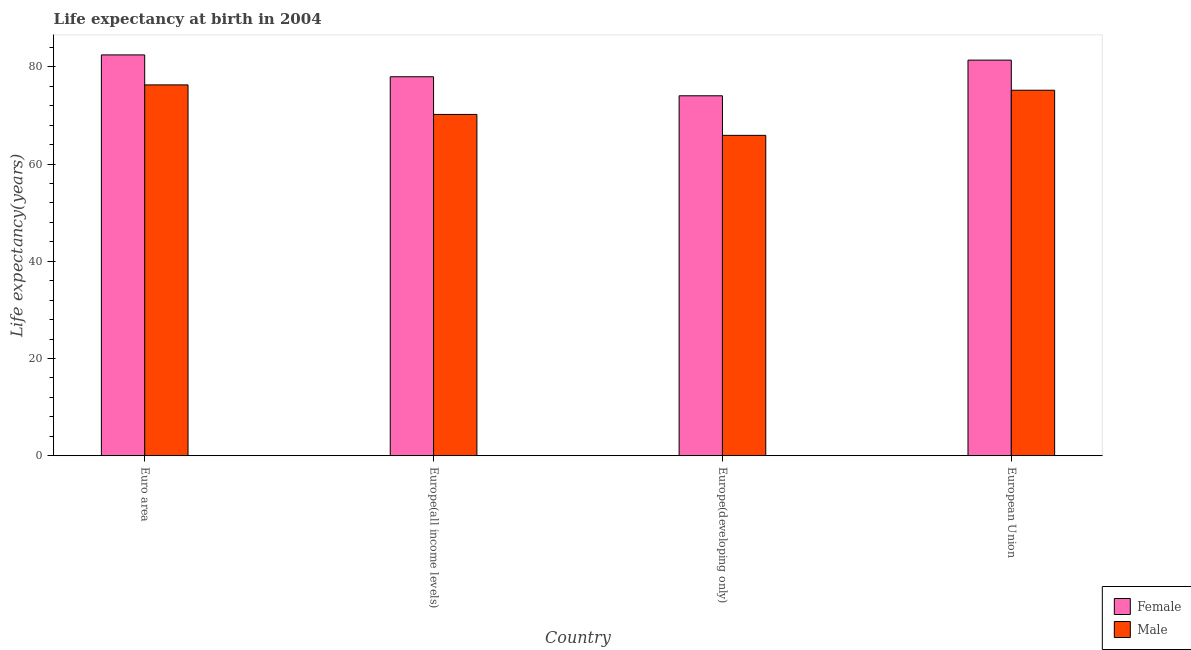How many different coloured bars are there?
Make the answer very short. 2. How many groups of bars are there?
Ensure brevity in your answer.  4. Are the number of bars per tick equal to the number of legend labels?
Offer a very short reply. Yes. What is the label of the 2nd group of bars from the left?
Your answer should be compact. Europe(all income levels). What is the life expectancy(male) in Europe(all income levels)?
Provide a short and direct response. 70.2. Across all countries, what is the maximum life expectancy(female)?
Your answer should be very brief. 82.44. Across all countries, what is the minimum life expectancy(male)?
Keep it short and to the point. 65.9. In which country was the life expectancy(female) minimum?
Make the answer very short. Europe(developing only). What is the total life expectancy(female) in the graph?
Keep it short and to the point. 315.79. What is the difference between the life expectancy(female) in Europe(developing only) and that in European Union?
Offer a terse response. -7.33. What is the difference between the life expectancy(female) in Euro area and the life expectancy(male) in Europe(developing only)?
Offer a very short reply. 16.54. What is the average life expectancy(female) per country?
Keep it short and to the point. 78.95. What is the difference between the life expectancy(female) and life expectancy(male) in European Union?
Your answer should be very brief. 6.19. In how many countries, is the life expectancy(male) greater than 32 years?
Give a very brief answer. 4. What is the ratio of the life expectancy(male) in Europe(developing only) to that in European Union?
Keep it short and to the point. 0.88. What is the difference between the highest and the second highest life expectancy(male)?
Provide a short and direct response. 1.1. What is the difference between the highest and the lowest life expectancy(female)?
Your answer should be compact. 8.41. Is the sum of the life expectancy(male) in Euro area and Europe(all income levels) greater than the maximum life expectancy(female) across all countries?
Give a very brief answer. Yes. What does the 2nd bar from the left in European Union represents?
Ensure brevity in your answer.  Male. What does the 2nd bar from the right in Euro area represents?
Make the answer very short. Female. How many bars are there?
Provide a succinct answer. 8. Are the values on the major ticks of Y-axis written in scientific E-notation?
Make the answer very short. No. Where does the legend appear in the graph?
Your response must be concise. Bottom right. What is the title of the graph?
Your response must be concise. Life expectancy at birth in 2004. Does "National Tourists" appear as one of the legend labels in the graph?
Your response must be concise. No. What is the label or title of the Y-axis?
Offer a very short reply. Life expectancy(years). What is the Life expectancy(years) of Female in Euro area?
Provide a succinct answer. 82.44. What is the Life expectancy(years) of Male in Euro area?
Your answer should be very brief. 76.27. What is the Life expectancy(years) of Female in Europe(all income levels)?
Your answer should be compact. 77.95. What is the Life expectancy(years) in Male in Europe(all income levels)?
Offer a terse response. 70.2. What is the Life expectancy(years) in Female in Europe(developing only)?
Offer a terse response. 74.03. What is the Life expectancy(years) in Male in Europe(developing only)?
Keep it short and to the point. 65.9. What is the Life expectancy(years) in Female in European Union?
Your response must be concise. 81.37. What is the Life expectancy(years) in Male in European Union?
Provide a short and direct response. 75.18. Across all countries, what is the maximum Life expectancy(years) of Female?
Ensure brevity in your answer.  82.44. Across all countries, what is the maximum Life expectancy(years) in Male?
Your answer should be very brief. 76.27. Across all countries, what is the minimum Life expectancy(years) in Female?
Your response must be concise. 74.03. Across all countries, what is the minimum Life expectancy(years) in Male?
Provide a short and direct response. 65.9. What is the total Life expectancy(years) in Female in the graph?
Your answer should be compact. 315.79. What is the total Life expectancy(years) in Male in the graph?
Give a very brief answer. 287.55. What is the difference between the Life expectancy(years) in Female in Euro area and that in Europe(all income levels)?
Your response must be concise. 4.49. What is the difference between the Life expectancy(years) in Male in Euro area and that in Europe(all income levels)?
Give a very brief answer. 6.07. What is the difference between the Life expectancy(years) in Female in Euro area and that in Europe(developing only)?
Your answer should be very brief. 8.41. What is the difference between the Life expectancy(years) of Male in Euro area and that in Europe(developing only)?
Offer a very short reply. 10.38. What is the difference between the Life expectancy(years) in Female in Euro area and that in European Union?
Ensure brevity in your answer.  1.07. What is the difference between the Life expectancy(years) of Male in Euro area and that in European Union?
Provide a succinct answer. 1.1. What is the difference between the Life expectancy(years) of Female in Europe(all income levels) and that in Europe(developing only)?
Ensure brevity in your answer.  3.91. What is the difference between the Life expectancy(years) of Male in Europe(all income levels) and that in Europe(developing only)?
Offer a terse response. 4.3. What is the difference between the Life expectancy(years) in Female in Europe(all income levels) and that in European Union?
Your response must be concise. -3.42. What is the difference between the Life expectancy(years) in Male in Europe(all income levels) and that in European Union?
Provide a short and direct response. -4.98. What is the difference between the Life expectancy(years) of Female in Europe(developing only) and that in European Union?
Provide a short and direct response. -7.33. What is the difference between the Life expectancy(years) of Male in Europe(developing only) and that in European Union?
Your response must be concise. -9.28. What is the difference between the Life expectancy(years) of Female in Euro area and the Life expectancy(years) of Male in Europe(all income levels)?
Make the answer very short. 12.24. What is the difference between the Life expectancy(years) in Female in Euro area and the Life expectancy(years) in Male in Europe(developing only)?
Your answer should be very brief. 16.54. What is the difference between the Life expectancy(years) in Female in Euro area and the Life expectancy(years) in Male in European Union?
Provide a succinct answer. 7.26. What is the difference between the Life expectancy(years) in Female in Europe(all income levels) and the Life expectancy(years) in Male in Europe(developing only)?
Your answer should be compact. 12.05. What is the difference between the Life expectancy(years) in Female in Europe(all income levels) and the Life expectancy(years) in Male in European Union?
Your answer should be compact. 2.77. What is the difference between the Life expectancy(years) of Female in Europe(developing only) and the Life expectancy(years) of Male in European Union?
Make the answer very short. -1.14. What is the average Life expectancy(years) in Female per country?
Make the answer very short. 78.95. What is the average Life expectancy(years) in Male per country?
Offer a very short reply. 71.89. What is the difference between the Life expectancy(years) of Female and Life expectancy(years) of Male in Euro area?
Make the answer very short. 6.17. What is the difference between the Life expectancy(years) of Female and Life expectancy(years) of Male in Europe(all income levels)?
Keep it short and to the point. 7.75. What is the difference between the Life expectancy(years) of Female and Life expectancy(years) of Male in Europe(developing only)?
Give a very brief answer. 8.14. What is the difference between the Life expectancy(years) of Female and Life expectancy(years) of Male in European Union?
Ensure brevity in your answer.  6.19. What is the ratio of the Life expectancy(years) of Female in Euro area to that in Europe(all income levels)?
Offer a very short reply. 1.06. What is the ratio of the Life expectancy(years) of Male in Euro area to that in Europe(all income levels)?
Provide a succinct answer. 1.09. What is the ratio of the Life expectancy(years) of Female in Euro area to that in Europe(developing only)?
Offer a very short reply. 1.11. What is the ratio of the Life expectancy(years) of Male in Euro area to that in Europe(developing only)?
Keep it short and to the point. 1.16. What is the ratio of the Life expectancy(years) in Female in Euro area to that in European Union?
Provide a succinct answer. 1.01. What is the ratio of the Life expectancy(years) of Male in Euro area to that in European Union?
Provide a succinct answer. 1.01. What is the ratio of the Life expectancy(years) in Female in Europe(all income levels) to that in Europe(developing only)?
Your response must be concise. 1.05. What is the ratio of the Life expectancy(years) in Male in Europe(all income levels) to that in Europe(developing only)?
Make the answer very short. 1.07. What is the ratio of the Life expectancy(years) of Female in Europe(all income levels) to that in European Union?
Your answer should be compact. 0.96. What is the ratio of the Life expectancy(years) in Male in Europe(all income levels) to that in European Union?
Your answer should be very brief. 0.93. What is the ratio of the Life expectancy(years) of Female in Europe(developing only) to that in European Union?
Offer a very short reply. 0.91. What is the ratio of the Life expectancy(years) in Male in Europe(developing only) to that in European Union?
Give a very brief answer. 0.88. What is the difference between the highest and the second highest Life expectancy(years) of Female?
Ensure brevity in your answer.  1.07. What is the difference between the highest and the second highest Life expectancy(years) in Male?
Offer a terse response. 1.1. What is the difference between the highest and the lowest Life expectancy(years) in Female?
Provide a short and direct response. 8.41. What is the difference between the highest and the lowest Life expectancy(years) of Male?
Your answer should be compact. 10.38. 